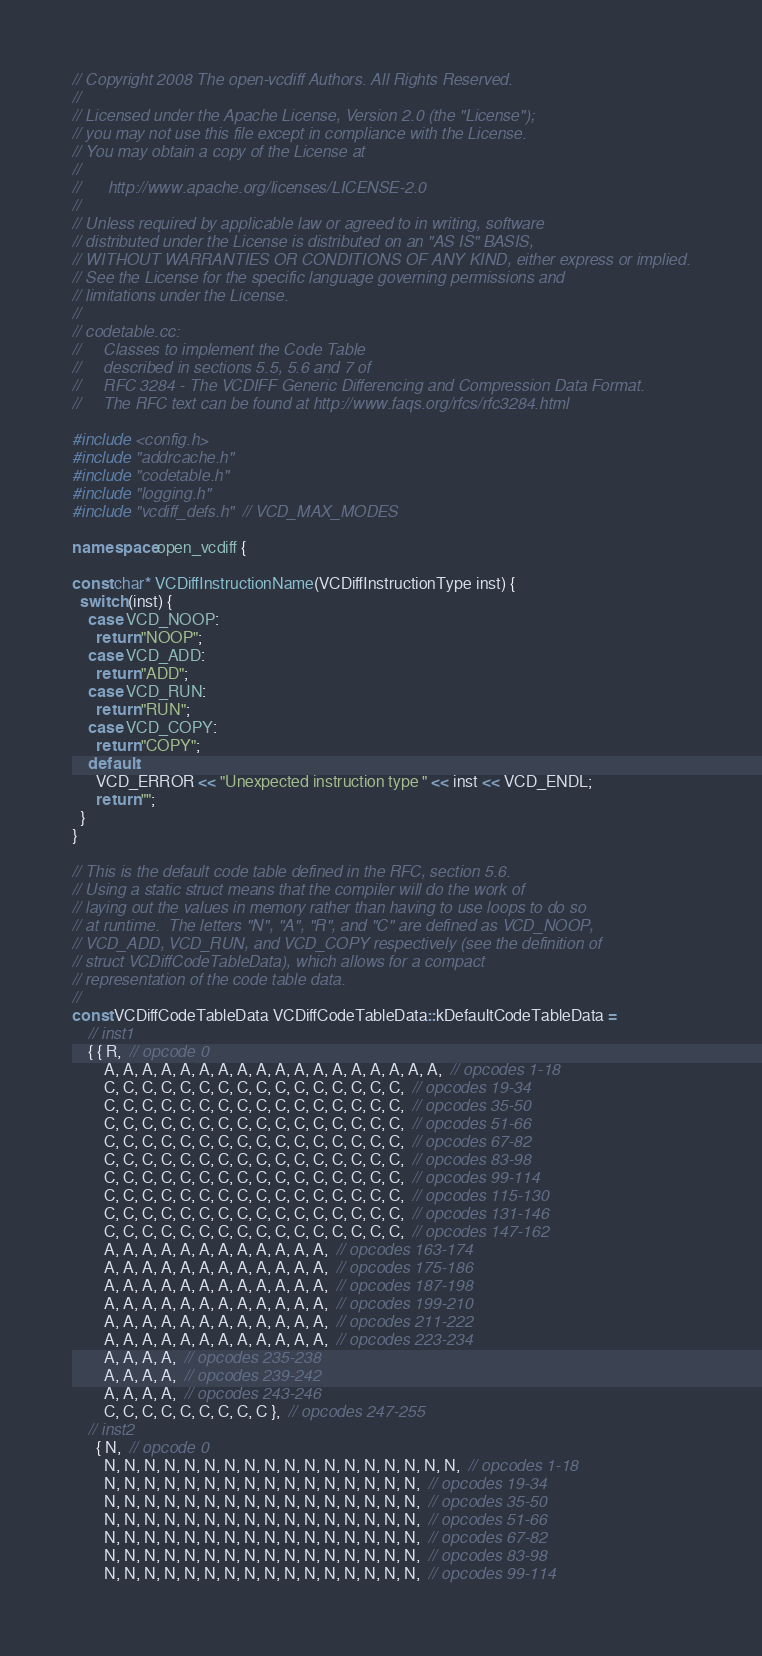<code> <loc_0><loc_0><loc_500><loc_500><_C++_>// Copyright 2008 The open-vcdiff Authors. All Rights Reserved.
//
// Licensed under the Apache License, Version 2.0 (the "License");
// you may not use this file except in compliance with the License.
// You may obtain a copy of the License at
//
//      http://www.apache.org/licenses/LICENSE-2.0
//
// Unless required by applicable law or agreed to in writing, software
// distributed under the License is distributed on an "AS IS" BASIS,
// WITHOUT WARRANTIES OR CONDITIONS OF ANY KIND, either express or implied.
// See the License for the specific language governing permissions and
// limitations under the License.
//
// codetable.cc:
//     Classes to implement the Code Table
//     described in sections 5.5, 5.6 and 7 of
//     RFC 3284 - The VCDIFF Generic Differencing and Compression Data Format.
//     The RFC text can be found at http://www.faqs.org/rfcs/rfc3284.html

#include <config.h>
#include "addrcache.h"
#include "codetable.h"
#include "logging.h"
#include "vcdiff_defs.h"  // VCD_MAX_MODES

namespace open_vcdiff {

const char* VCDiffInstructionName(VCDiffInstructionType inst) {
  switch (inst) {
    case VCD_NOOP:
      return "NOOP";
    case VCD_ADD:
      return "ADD";
    case VCD_RUN:
      return "RUN";
    case VCD_COPY:
      return "COPY";
    default:
      VCD_ERROR << "Unexpected instruction type " << inst << VCD_ENDL;
      return "";
  }
}

// This is the default code table defined in the RFC, section 5.6.
// Using a static struct means that the compiler will do the work of
// laying out the values in memory rather than having to use loops to do so
// at runtime.  The letters "N", "A", "R", and "C" are defined as VCD_NOOP,
// VCD_ADD, VCD_RUN, and VCD_COPY respectively (see the definition of
// struct VCDiffCodeTableData), which allows for a compact
// representation of the code table data.
//
const VCDiffCodeTableData VCDiffCodeTableData::kDefaultCodeTableData =
    // inst1
    { { R,  // opcode 0
        A, A, A, A, A, A, A, A, A, A, A, A, A, A, A, A, A, A,  // opcodes 1-18
        C, C, C, C, C, C, C, C, C, C, C, C, C, C, C, C,  // opcodes 19-34
        C, C, C, C, C, C, C, C, C, C, C, C, C, C, C, C,  // opcodes 35-50
        C, C, C, C, C, C, C, C, C, C, C, C, C, C, C, C,  // opcodes 51-66
        C, C, C, C, C, C, C, C, C, C, C, C, C, C, C, C,  // opcodes 67-82
        C, C, C, C, C, C, C, C, C, C, C, C, C, C, C, C,  // opcodes 83-98
        C, C, C, C, C, C, C, C, C, C, C, C, C, C, C, C,  // opcodes 99-114
        C, C, C, C, C, C, C, C, C, C, C, C, C, C, C, C,  // opcodes 115-130
        C, C, C, C, C, C, C, C, C, C, C, C, C, C, C, C,  // opcodes 131-146
        C, C, C, C, C, C, C, C, C, C, C, C, C, C, C, C,  // opcodes 147-162
        A, A, A, A, A, A, A, A, A, A, A, A,  // opcodes 163-174
        A, A, A, A, A, A, A, A, A, A, A, A,  // opcodes 175-186
        A, A, A, A, A, A, A, A, A, A, A, A,  // opcodes 187-198
        A, A, A, A, A, A, A, A, A, A, A, A,  // opcodes 199-210
        A, A, A, A, A, A, A, A, A, A, A, A,  // opcodes 211-222
        A, A, A, A, A, A, A, A, A, A, A, A,  // opcodes 223-234
        A, A, A, A,  // opcodes 235-238
        A, A, A, A,  // opcodes 239-242
        A, A, A, A,  // opcodes 243-246
        C, C, C, C, C, C, C, C, C },  // opcodes 247-255
    // inst2
      { N,  // opcode 0
        N, N, N, N, N, N, N, N, N, N, N, N, N, N, N, N, N, N,  // opcodes 1-18
        N, N, N, N, N, N, N, N, N, N, N, N, N, N, N, N,  // opcodes 19-34
        N, N, N, N, N, N, N, N, N, N, N, N, N, N, N, N,  // opcodes 35-50
        N, N, N, N, N, N, N, N, N, N, N, N, N, N, N, N,  // opcodes 51-66
        N, N, N, N, N, N, N, N, N, N, N, N, N, N, N, N,  // opcodes 67-82
        N, N, N, N, N, N, N, N, N, N, N, N, N, N, N, N,  // opcodes 83-98
        N, N, N, N, N, N, N, N, N, N, N, N, N, N, N, N,  // opcodes 99-114</code> 